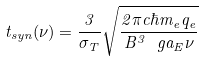<formula> <loc_0><loc_0><loc_500><loc_500>t _ { s y n } ( \nu ) = \frac { 3 } { \sigma _ { T } } \sqrt { \frac { 2 \pi c \hbar { m } _ { e } q _ { e } } { B ^ { 3 } \ g a _ { E } \nu } }</formula> 